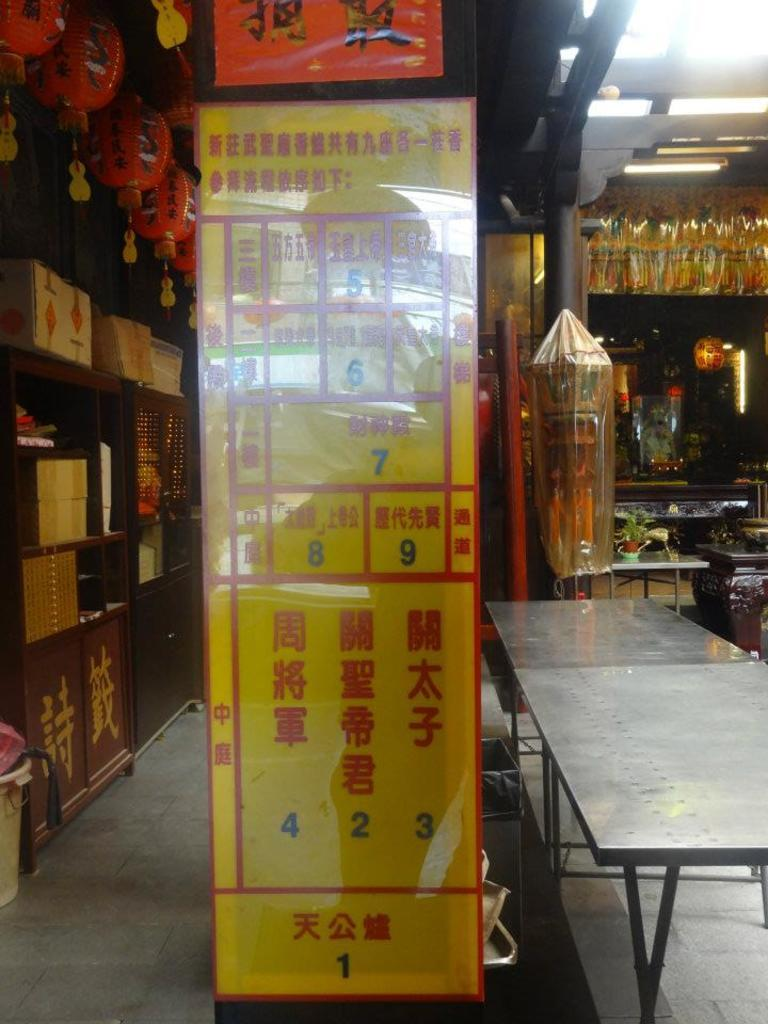What is the main object in the image? There is a board in the image. What can be seen on the board? There is text on the board. What is located on the right side of the image? There is a table on the right side of the image. What is visible in the background of the image? There are racks in the background of the image. What is on the racks? There are items on the racks. How many fruits are on the board in the image? There is no fruit present on the board in the image. What type of rat can be seen hiding behind the racks in the image? There is no rat present in the image. 